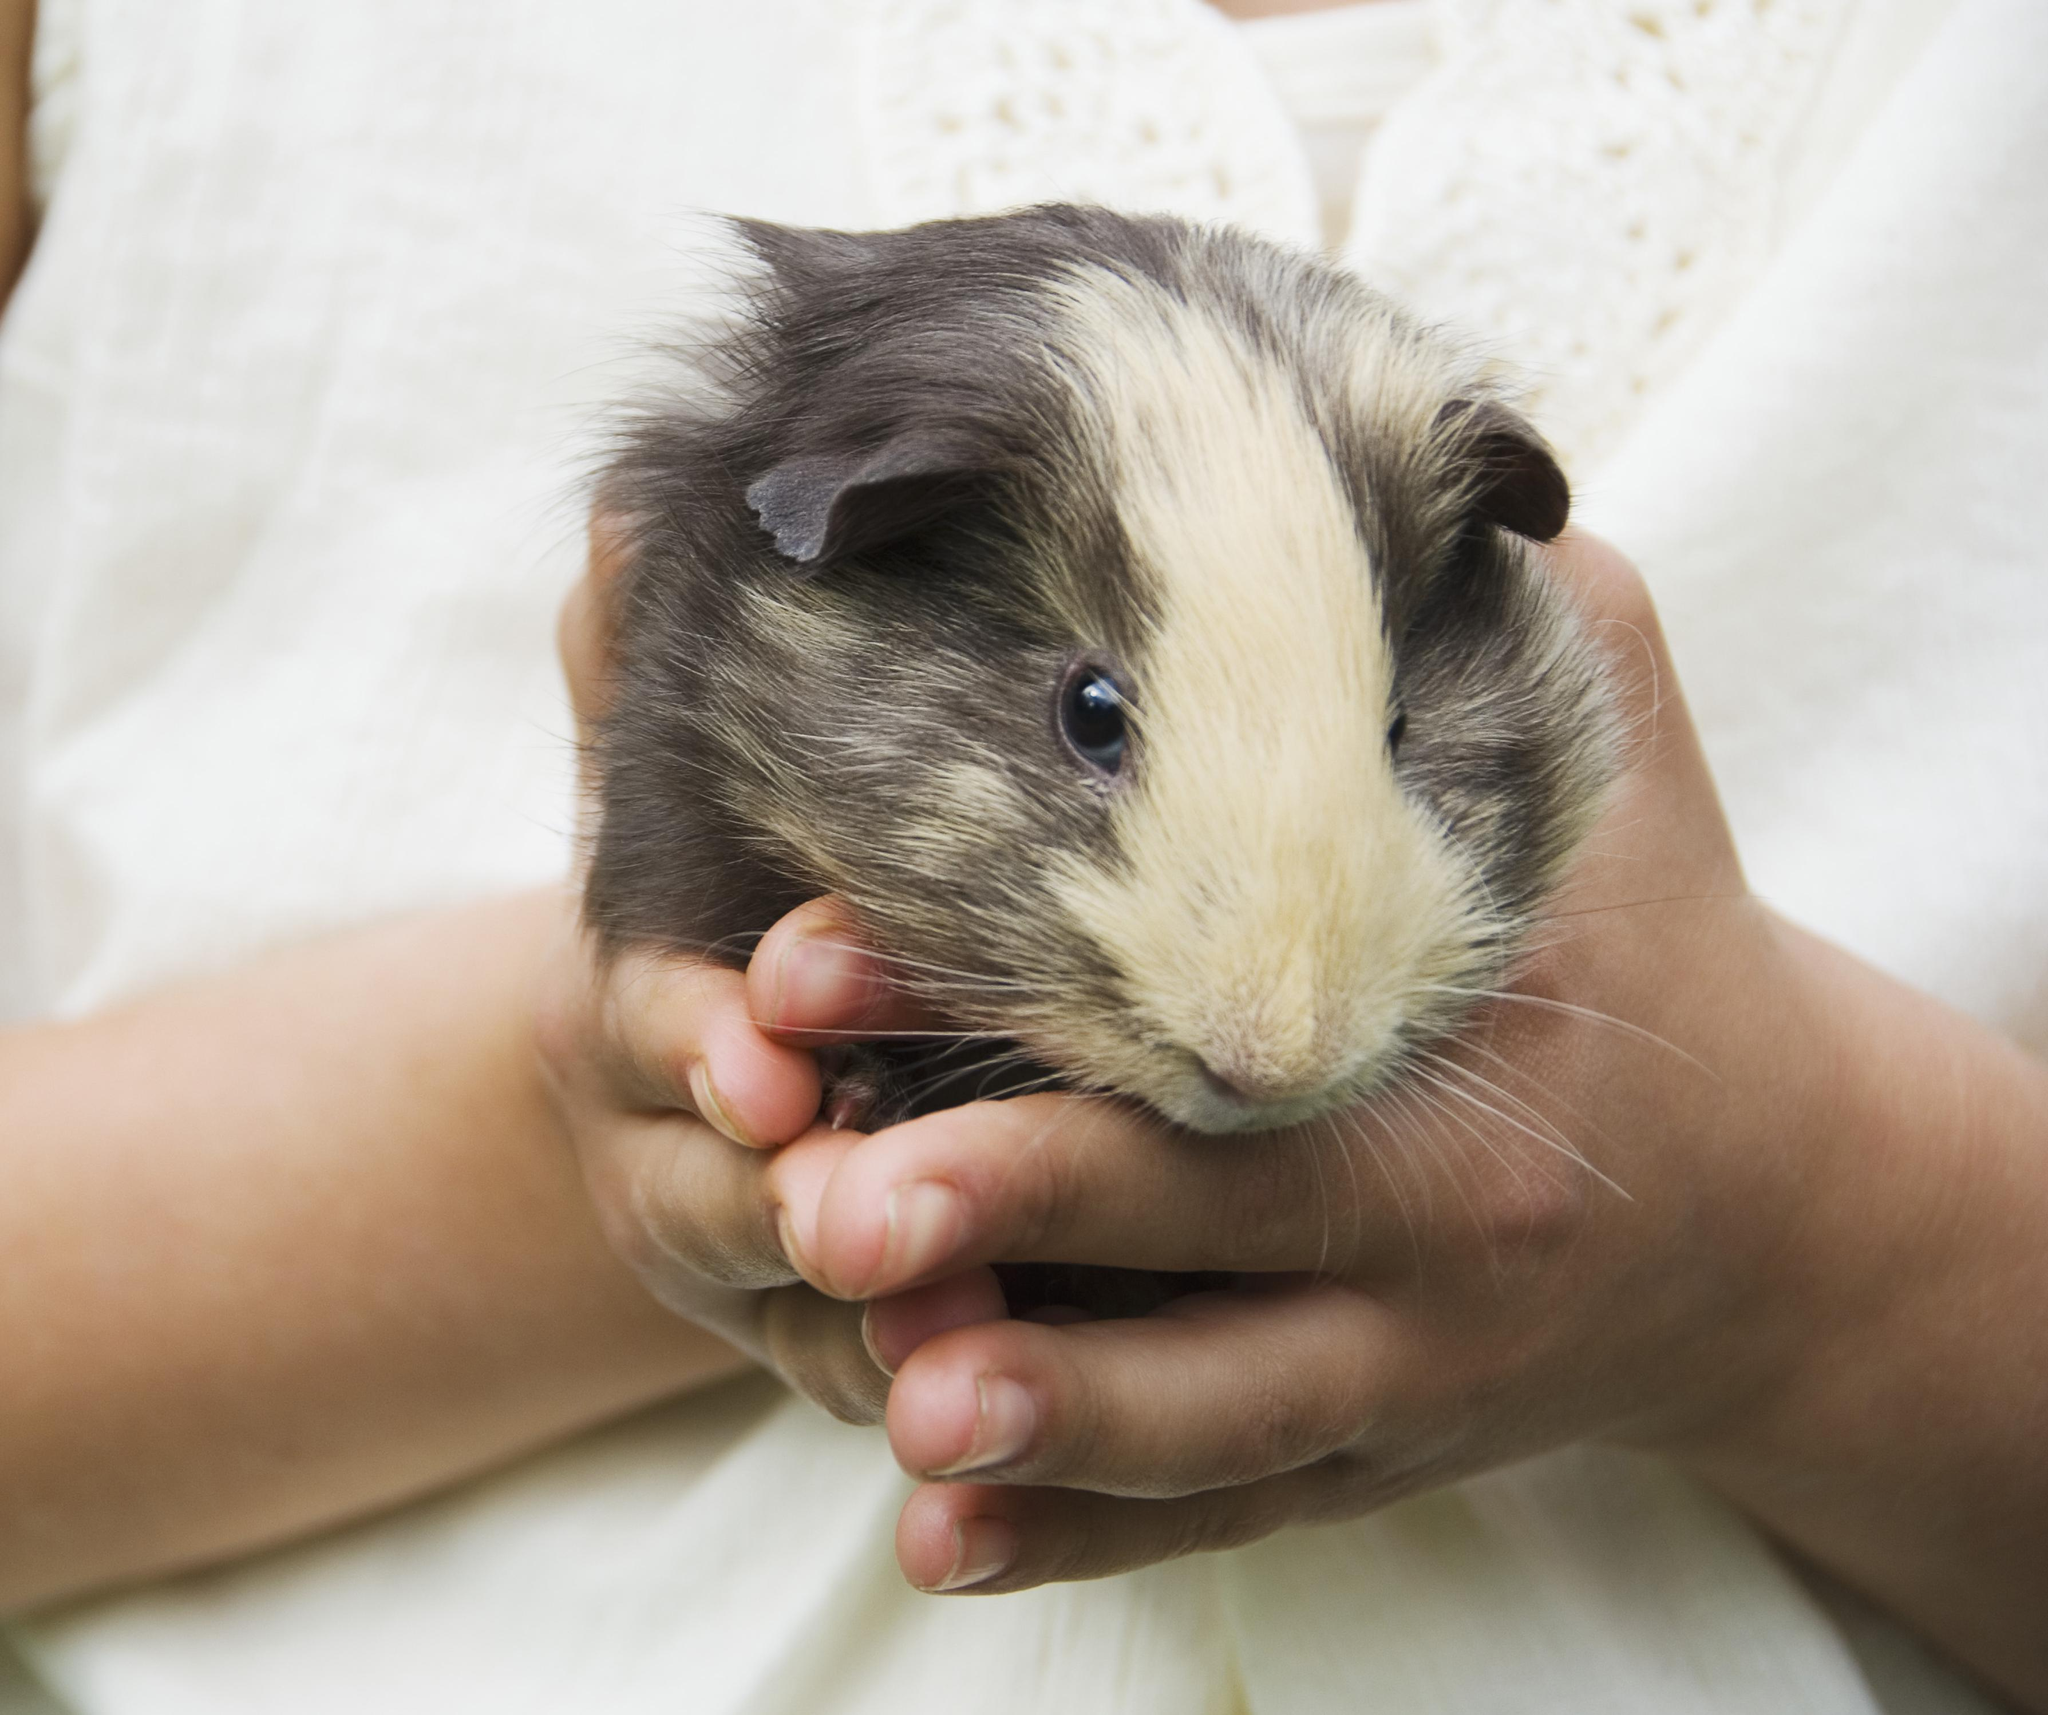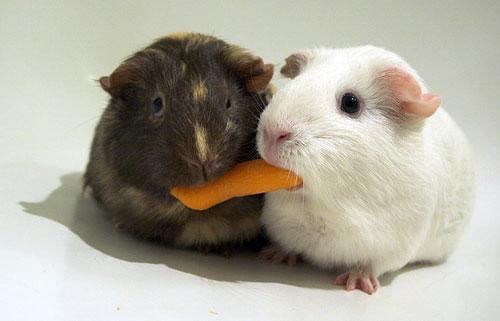The first image is the image on the left, the second image is the image on the right. Evaluate the accuracy of this statement regarding the images: "There is at least one rodent sitting on the grass in the image on the right.". Is it true? Answer yes or no. No. The first image is the image on the left, the second image is the image on the right. Examine the images to the left and right. Is the description "The right image shows two guinea pigs and the left shows only one, and one of the images includes a bright orange object." accurate? Answer yes or no. Yes. 